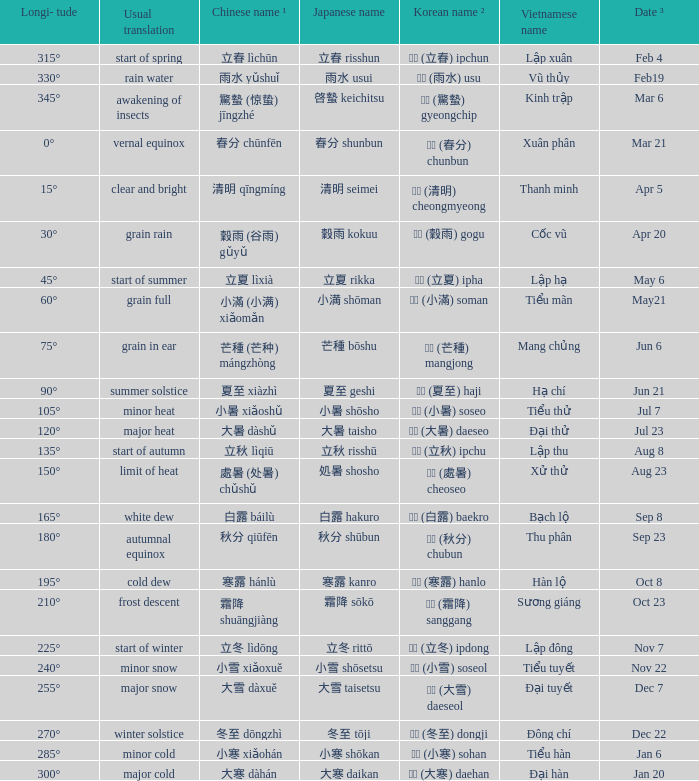When has a Korean name ² of 청명 (清明) cheongmyeong? Apr 5. 